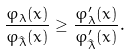<formula> <loc_0><loc_0><loc_500><loc_500>\frac { \varphi _ { \lambda } ( x ) } { \varphi _ { \hat { \lambda } } ( x ) } \geq \frac { \varphi _ { \lambda } ^ { \prime } ( x ) } { \varphi _ { \hat { \lambda } } ^ { \prime } ( x ) } .</formula> 